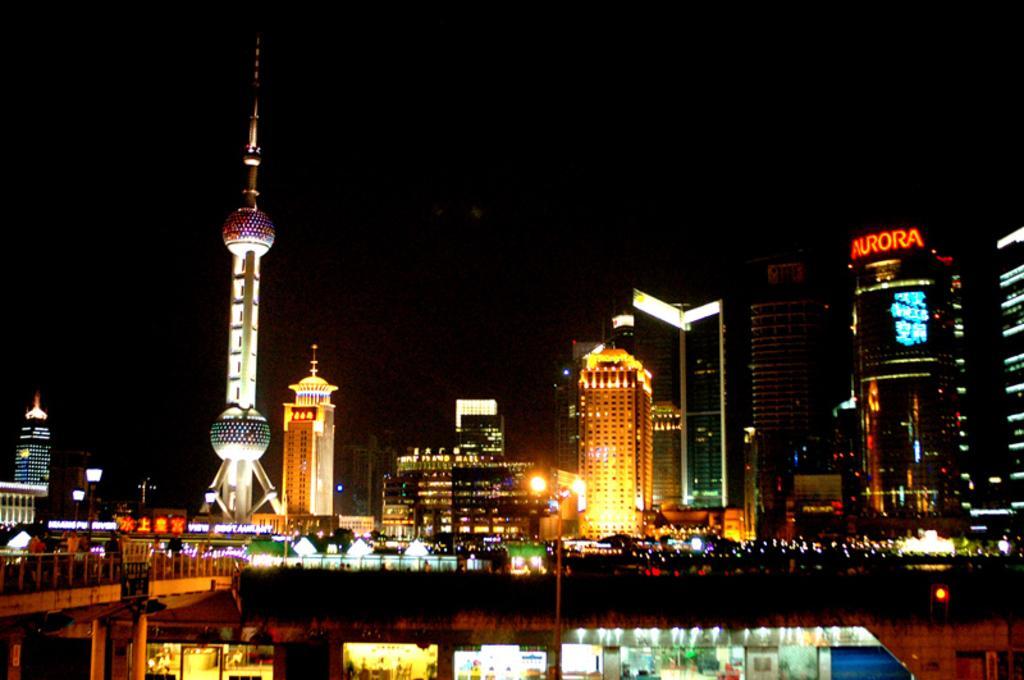In one or two sentences, can you explain what this image depicts? In this image there are many buildings, towers. This is a bridge. Here there are shops. 